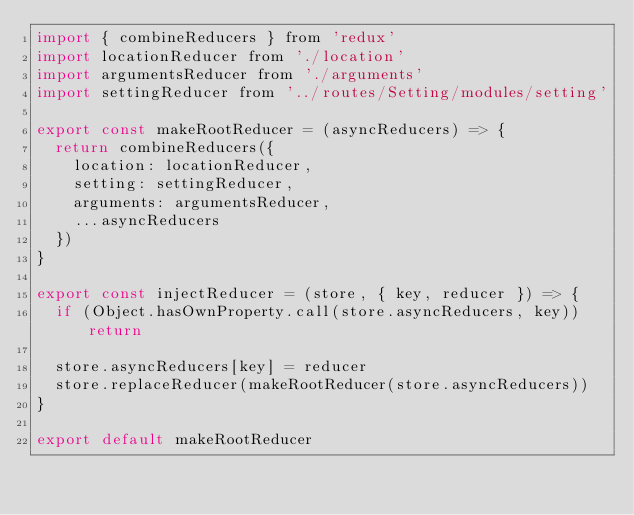<code> <loc_0><loc_0><loc_500><loc_500><_JavaScript_>import { combineReducers } from 'redux'
import locationReducer from './location'
import argumentsReducer from './arguments'
import settingReducer from '../routes/Setting/modules/setting'

export const makeRootReducer = (asyncReducers) => {
  return combineReducers({
    location: locationReducer,
    setting: settingReducer,
    arguments: argumentsReducer,
    ...asyncReducers
  })
}

export const injectReducer = (store, { key, reducer }) => {
  if (Object.hasOwnProperty.call(store.asyncReducers, key)) return

  store.asyncReducers[key] = reducer
  store.replaceReducer(makeRootReducer(store.asyncReducers))
}

export default makeRootReducer
</code> 